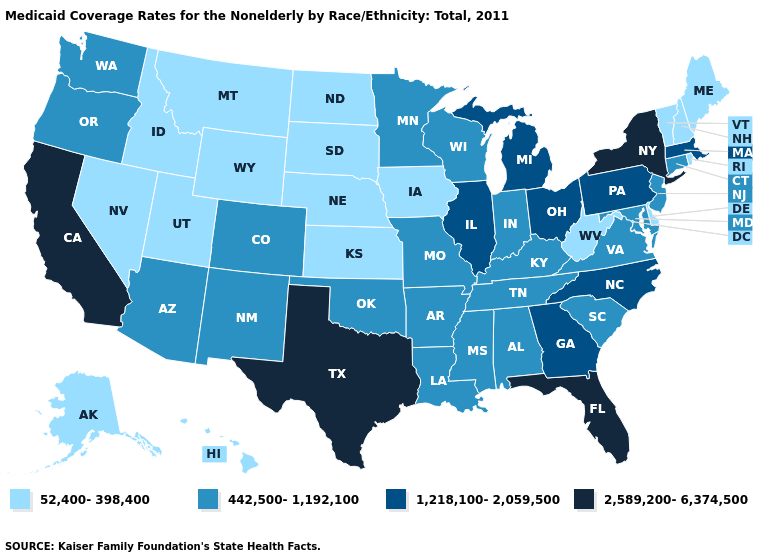Which states have the lowest value in the MidWest?
Quick response, please. Iowa, Kansas, Nebraska, North Dakota, South Dakota. What is the value of Idaho?
Keep it brief. 52,400-398,400. Is the legend a continuous bar?
Answer briefly. No. Which states have the highest value in the USA?
Give a very brief answer. California, Florida, New York, Texas. Does Mississippi have a higher value than Louisiana?
Answer briefly. No. What is the value of South Carolina?
Give a very brief answer. 442,500-1,192,100. Which states have the lowest value in the USA?
Give a very brief answer. Alaska, Delaware, Hawaii, Idaho, Iowa, Kansas, Maine, Montana, Nebraska, Nevada, New Hampshire, North Dakota, Rhode Island, South Dakota, Utah, Vermont, West Virginia, Wyoming. What is the value of Washington?
Be succinct. 442,500-1,192,100. What is the lowest value in the South?
Quick response, please. 52,400-398,400. Name the states that have a value in the range 442,500-1,192,100?
Write a very short answer. Alabama, Arizona, Arkansas, Colorado, Connecticut, Indiana, Kentucky, Louisiana, Maryland, Minnesota, Mississippi, Missouri, New Jersey, New Mexico, Oklahoma, Oregon, South Carolina, Tennessee, Virginia, Washington, Wisconsin. Does Florida have the lowest value in the South?
Give a very brief answer. No. What is the value of Nebraska?
Be succinct. 52,400-398,400. Name the states that have a value in the range 2,589,200-6,374,500?
Concise answer only. California, Florida, New York, Texas. What is the value of Ohio?
Quick response, please. 1,218,100-2,059,500. 